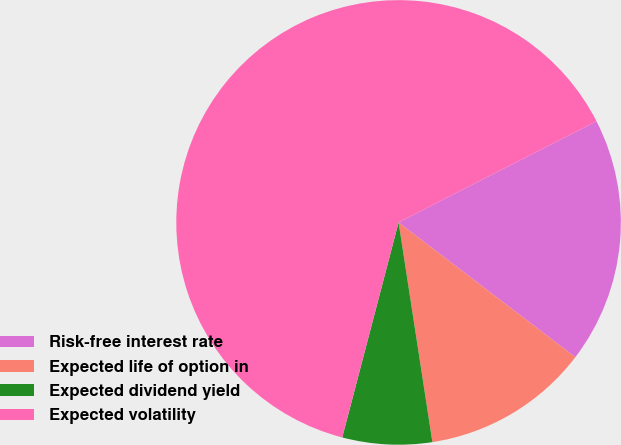Convert chart. <chart><loc_0><loc_0><loc_500><loc_500><pie_chart><fcel>Risk-free interest rate<fcel>Expected life of option in<fcel>Expected dividend yield<fcel>Expected volatility<nl><fcel>17.89%<fcel>12.2%<fcel>6.51%<fcel>63.4%<nl></chart> 